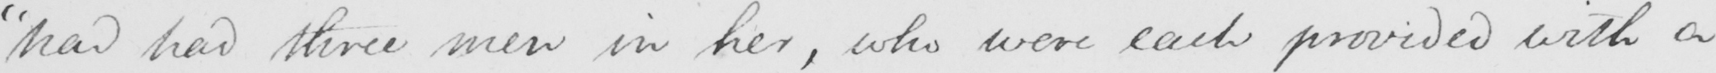What does this handwritten line say? " had had three men in her , who were each provided with a 